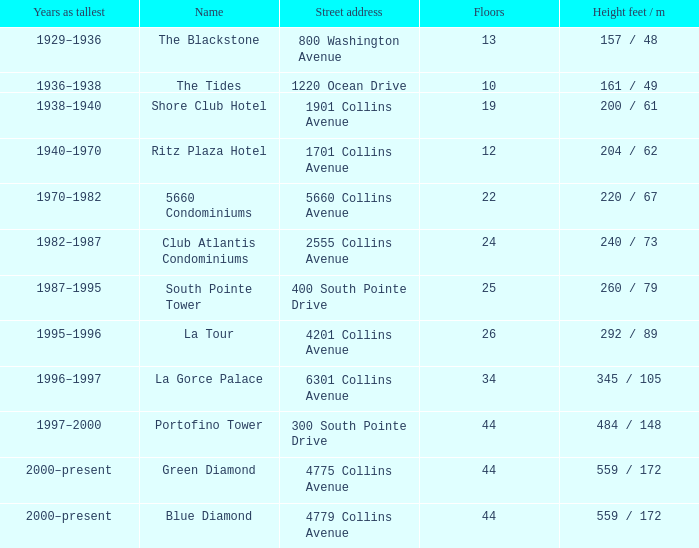How many floors does the Blue Diamond have? 44.0. 